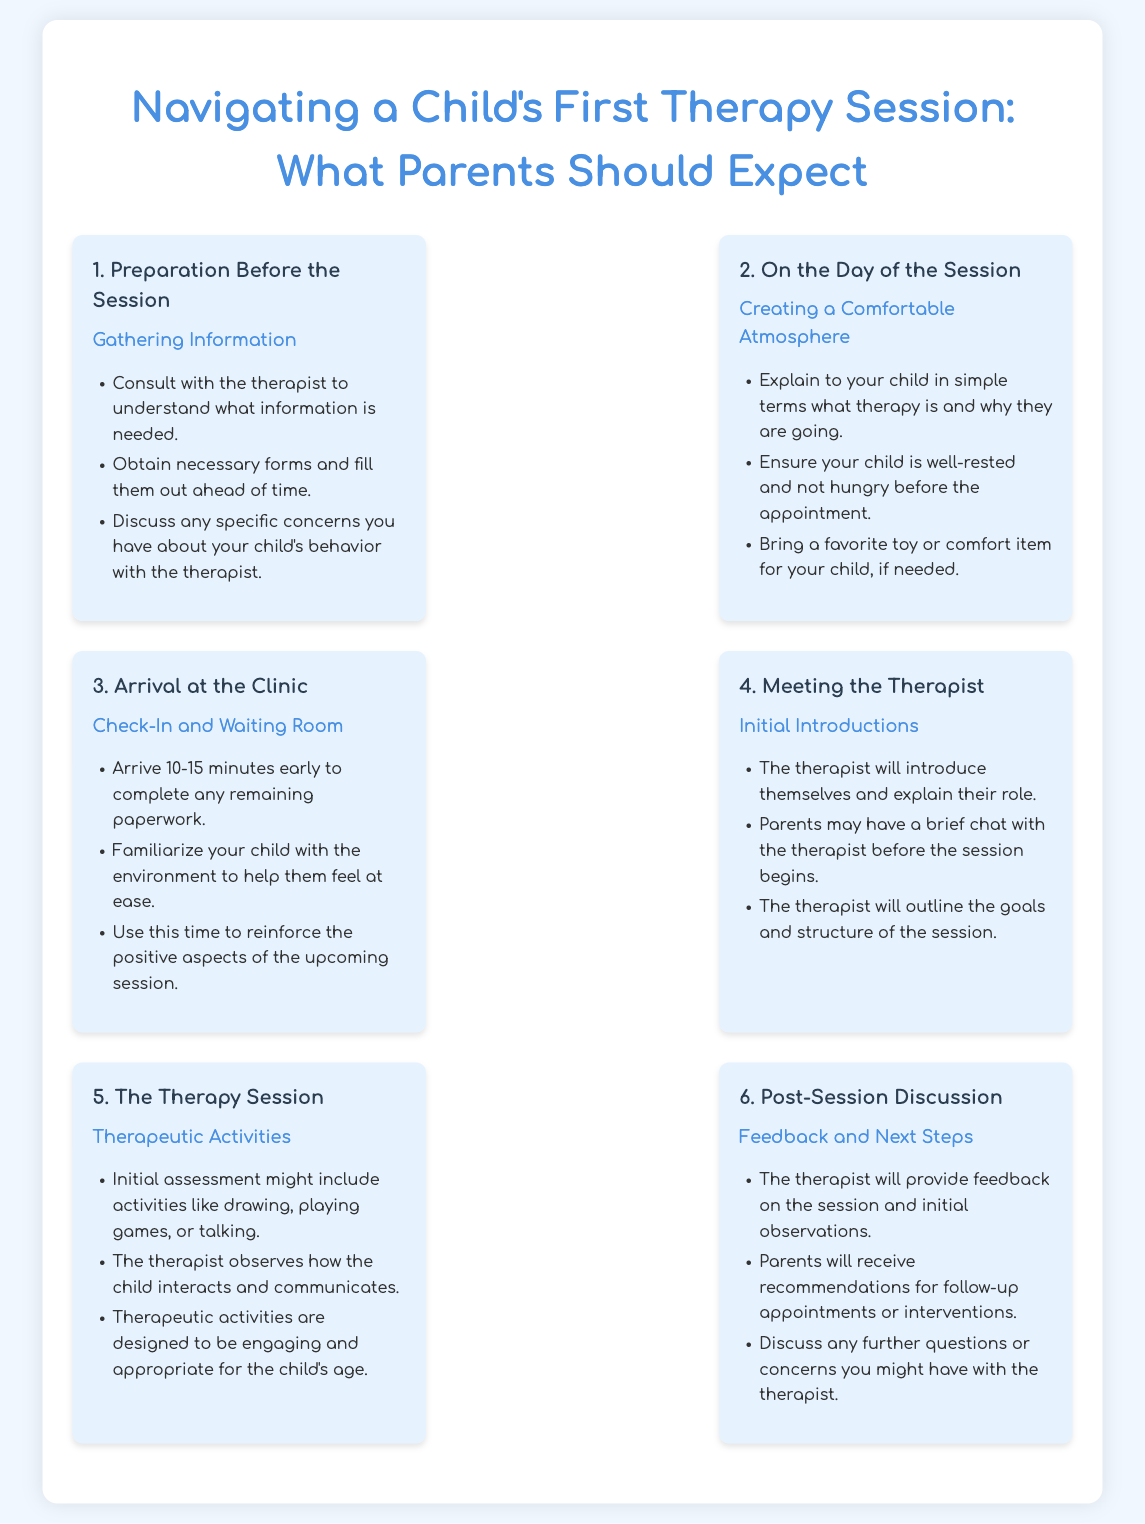What is the first step before the therapy session? The first step involves preparing for the session by gathering information, which includes consulting with the therapist and filling out forms.
Answer: Preparation Before the Session What should parents ensure about their child before the session? It's important for parents to ensure that their child is well-rested and not hungry to create a comfortable atmosphere.
Answer: Well-rested and not hungry How early should parents arrive at the clinic? Parents should arrive 10-15 minutes early to complete any remaining paperwork and help their child feel at ease.
Answer: 10-15 minutes early What type of activities might the therapist use during the session? The initial assessment might include engaging activities like drawing, playing games, or talking to observe the child's interactions.
Answer: Drawing, playing games, or talking What should parents discuss after the session? After the session, parents should discuss feedback, initial observations, and any further questions or concerns about their child's therapy.
Answer: Feedback and next steps What item can parents bring to help their child during the session? Parents can bring a favorite toy or comfort item to help make their child feel more secure and comfortable during the therapy session.
Answer: A favorite toy or comfort item 